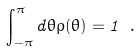<formula> <loc_0><loc_0><loc_500><loc_500>\int _ { - \pi } ^ { \pi } d \theta \rho ( \theta ) = 1 \ .</formula> 